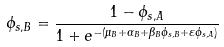<formula> <loc_0><loc_0><loc_500><loc_500>\phi _ { s , B } = \frac { 1 - \phi _ { s , A } } { 1 + e ^ { - ( \mu _ { B } + \alpha _ { B } + \beta _ { B } \phi _ { s , B } + \varepsilon \phi _ { s , A } ) } }</formula> 